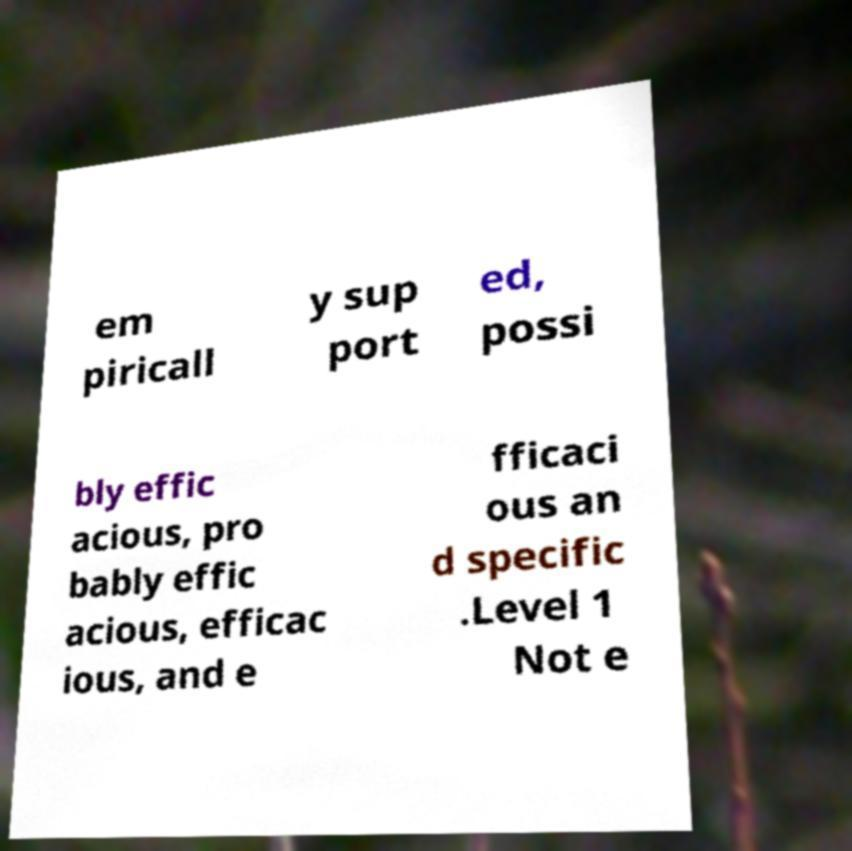Could you assist in decoding the text presented in this image and type it out clearly? em piricall y sup port ed, possi bly effic acious, pro bably effic acious, efficac ious, and e fficaci ous an d specific .Level 1 Not e 